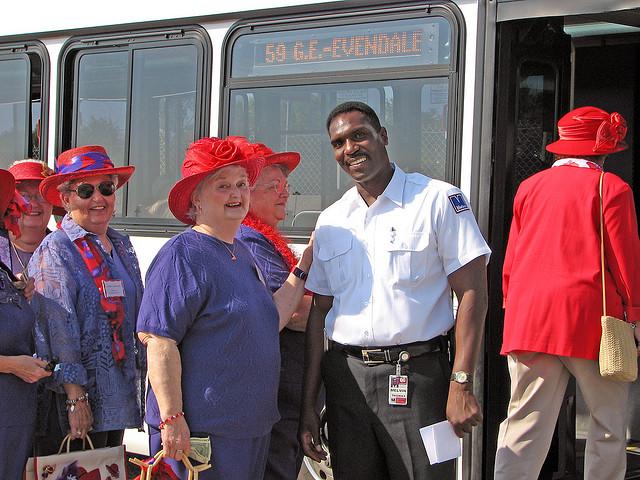Are there more women or men?
Short answer required. Women. What does the sign right above the man's head say?
Short answer required. 59 ge evendale. Is the black man wearing casual clothes?
Be succinct. No. 